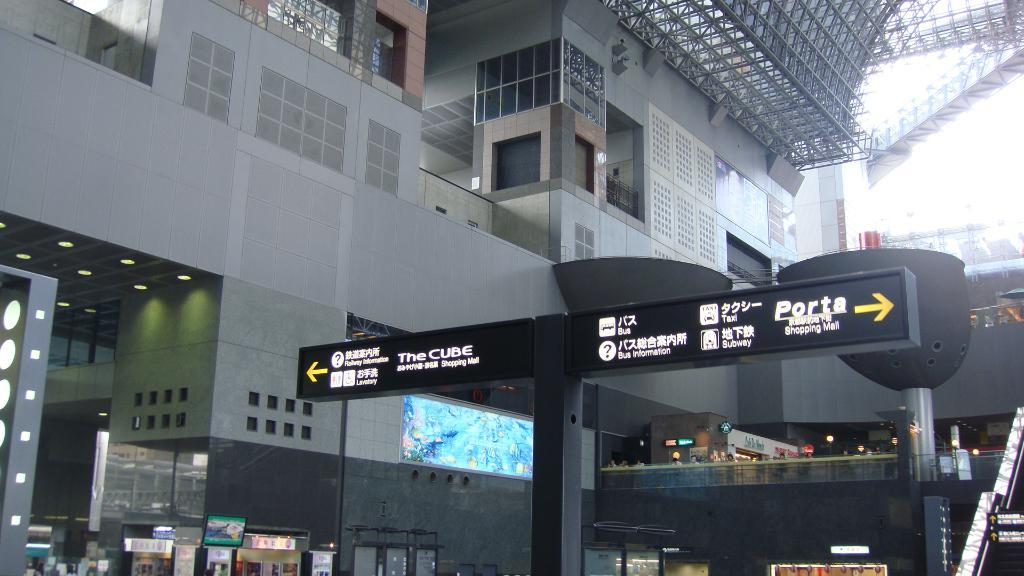What type of structure is visible in the image? There is a building in the image. What materials are used in the construction of the building? The building has glass and windows. What can be found inside the building? There are stalls inside the building. What is written or displayed on the stalls? The stalls have text on them. Is there a spy observing the building from the border in the image? There is no indication of a spy or a border in the image; it only shows a building with stalls inside. 